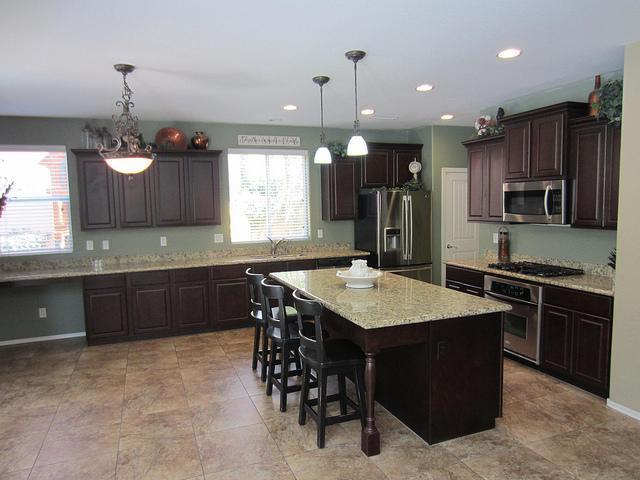What is the right side of the room mainly used for?
From the following set of four choices, select the accurate answer to respond to the question.
Options: Sleeping, gaming, bathing, cooking. Cooking. 